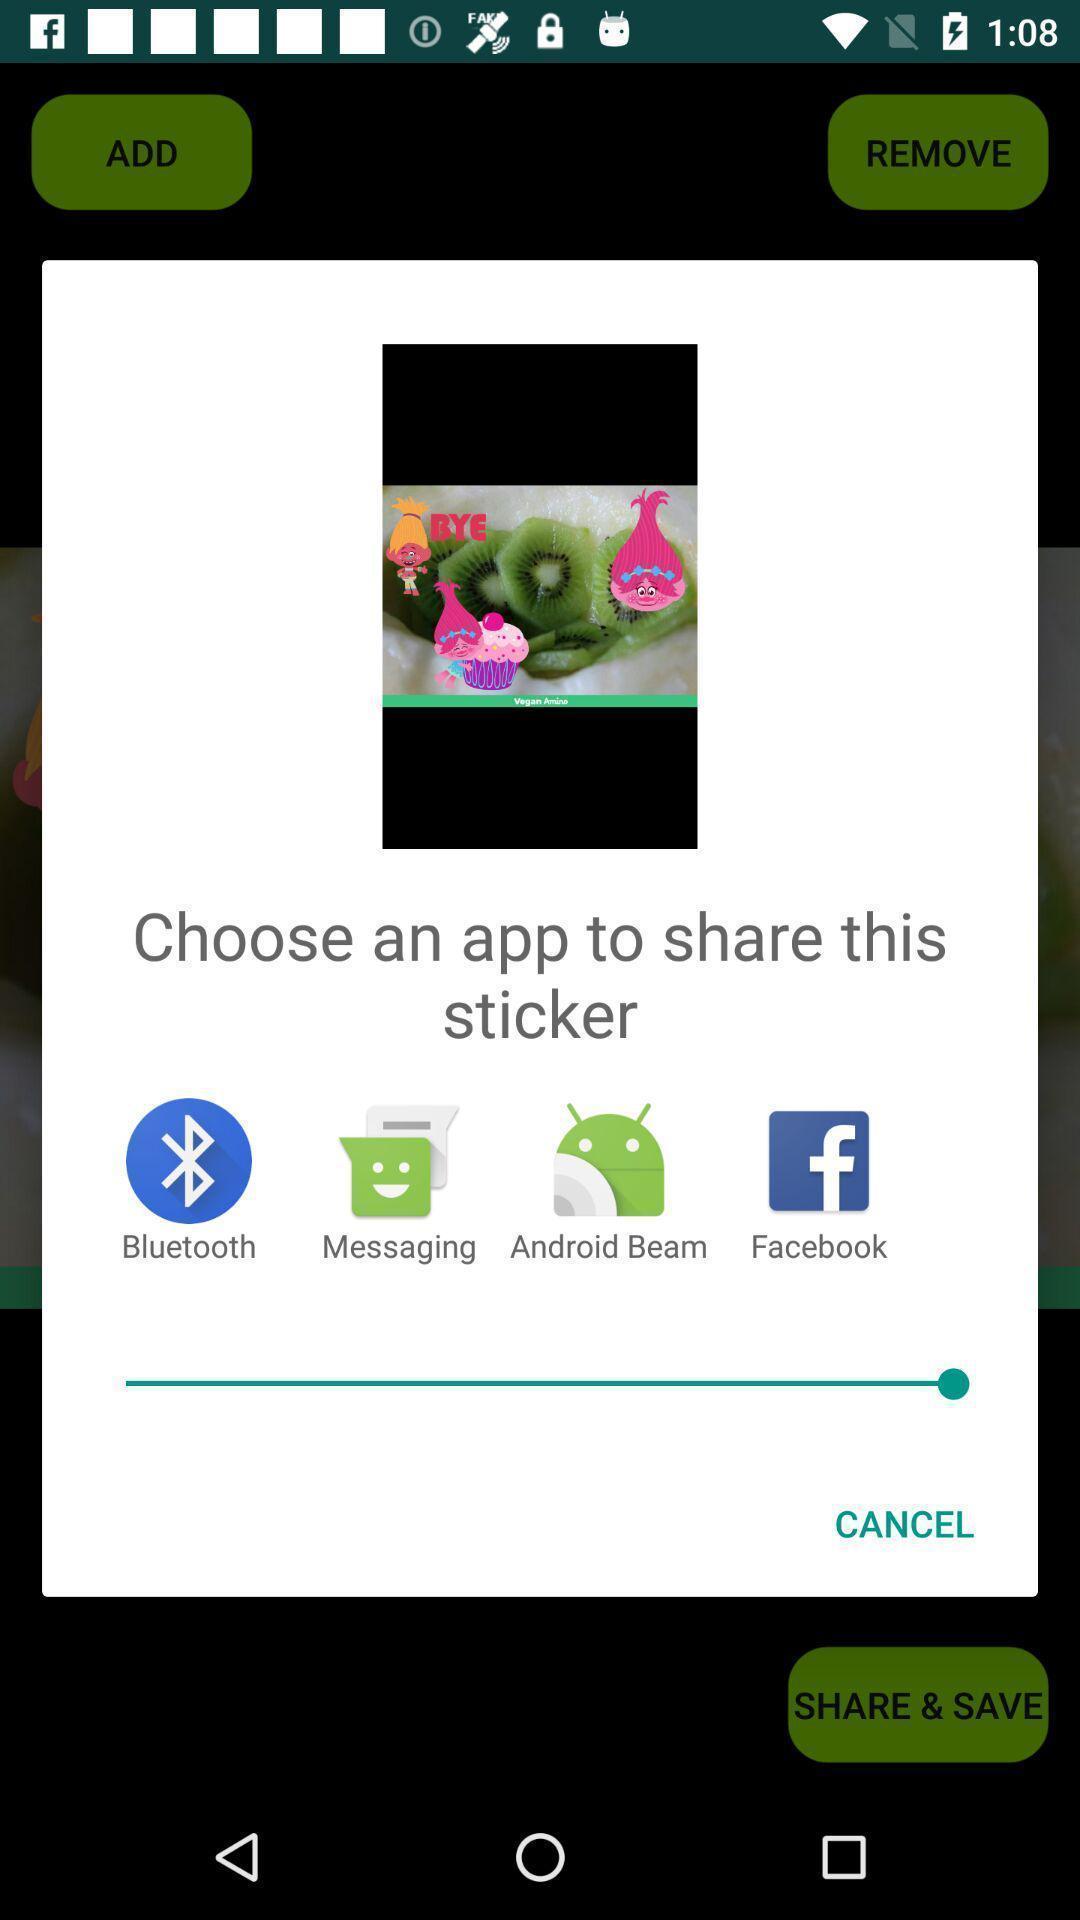What can you discern from this picture? Pop-up showing different sharing options for sticker sharing. 